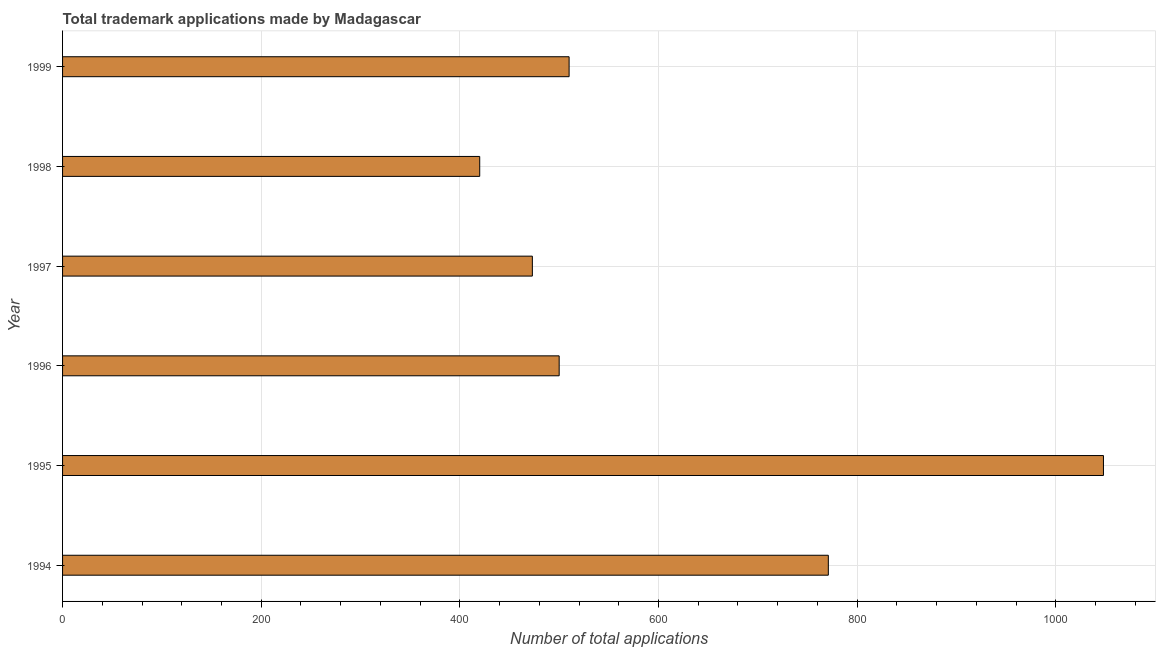Does the graph contain any zero values?
Provide a short and direct response. No. Does the graph contain grids?
Give a very brief answer. Yes. What is the title of the graph?
Your response must be concise. Total trademark applications made by Madagascar. What is the label or title of the X-axis?
Keep it short and to the point. Number of total applications. What is the label or title of the Y-axis?
Keep it short and to the point. Year. What is the number of trademark applications in 1998?
Ensure brevity in your answer.  420. Across all years, what is the maximum number of trademark applications?
Your response must be concise. 1048. Across all years, what is the minimum number of trademark applications?
Give a very brief answer. 420. What is the sum of the number of trademark applications?
Your response must be concise. 3722. What is the difference between the number of trademark applications in 1996 and 1999?
Ensure brevity in your answer.  -10. What is the average number of trademark applications per year?
Your answer should be very brief. 620. What is the median number of trademark applications?
Offer a very short reply. 505. In how many years, is the number of trademark applications greater than 320 ?
Provide a short and direct response. 6. What is the ratio of the number of trademark applications in 1997 to that in 1998?
Your response must be concise. 1.13. Is the number of trademark applications in 1997 less than that in 1999?
Make the answer very short. Yes. What is the difference between the highest and the second highest number of trademark applications?
Your answer should be very brief. 277. What is the difference between the highest and the lowest number of trademark applications?
Your answer should be compact. 628. What is the Number of total applications of 1994?
Give a very brief answer. 771. What is the Number of total applications of 1995?
Your answer should be compact. 1048. What is the Number of total applications of 1996?
Keep it short and to the point. 500. What is the Number of total applications in 1997?
Your answer should be very brief. 473. What is the Number of total applications of 1998?
Offer a very short reply. 420. What is the Number of total applications in 1999?
Provide a succinct answer. 510. What is the difference between the Number of total applications in 1994 and 1995?
Offer a terse response. -277. What is the difference between the Number of total applications in 1994 and 1996?
Give a very brief answer. 271. What is the difference between the Number of total applications in 1994 and 1997?
Your answer should be very brief. 298. What is the difference between the Number of total applications in 1994 and 1998?
Your answer should be compact. 351. What is the difference between the Number of total applications in 1994 and 1999?
Your answer should be compact. 261. What is the difference between the Number of total applications in 1995 and 1996?
Your response must be concise. 548. What is the difference between the Number of total applications in 1995 and 1997?
Provide a succinct answer. 575. What is the difference between the Number of total applications in 1995 and 1998?
Your response must be concise. 628. What is the difference between the Number of total applications in 1995 and 1999?
Your answer should be compact. 538. What is the difference between the Number of total applications in 1997 and 1999?
Give a very brief answer. -37. What is the difference between the Number of total applications in 1998 and 1999?
Offer a terse response. -90. What is the ratio of the Number of total applications in 1994 to that in 1995?
Provide a succinct answer. 0.74. What is the ratio of the Number of total applications in 1994 to that in 1996?
Ensure brevity in your answer.  1.54. What is the ratio of the Number of total applications in 1994 to that in 1997?
Make the answer very short. 1.63. What is the ratio of the Number of total applications in 1994 to that in 1998?
Your answer should be compact. 1.84. What is the ratio of the Number of total applications in 1994 to that in 1999?
Ensure brevity in your answer.  1.51. What is the ratio of the Number of total applications in 1995 to that in 1996?
Your answer should be compact. 2.1. What is the ratio of the Number of total applications in 1995 to that in 1997?
Give a very brief answer. 2.22. What is the ratio of the Number of total applications in 1995 to that in 1998?
Your answer should be very brief. 2.5. What is the ratio of the Number of total applications in 1995 to that in 1999?
Your answer should be compact. 2.06. What is the ratio of the Number of total applications in 1996 to that in 1997?
Provide a succinct answer. 1.06. What is the ratio of the Number of total applications in 1996 to that in 1998?
Your answer should be very brief. 1.19. What is the ratio of the Number of total applications in 1996 to that in 1999?
Your answer should be very brief. 0.98. What is the ratio of the Number of total applications in 1997 to that in 1998?
Provide a short and direct response. 1.13. What is the ratio of the Number of total applications in 1997 to that in 1999?
Your answer should be very brief. 0.93. What is the ratio of the Number of total applications in 1998 to that in 1999?
Offer a very short reply. 0.82. 